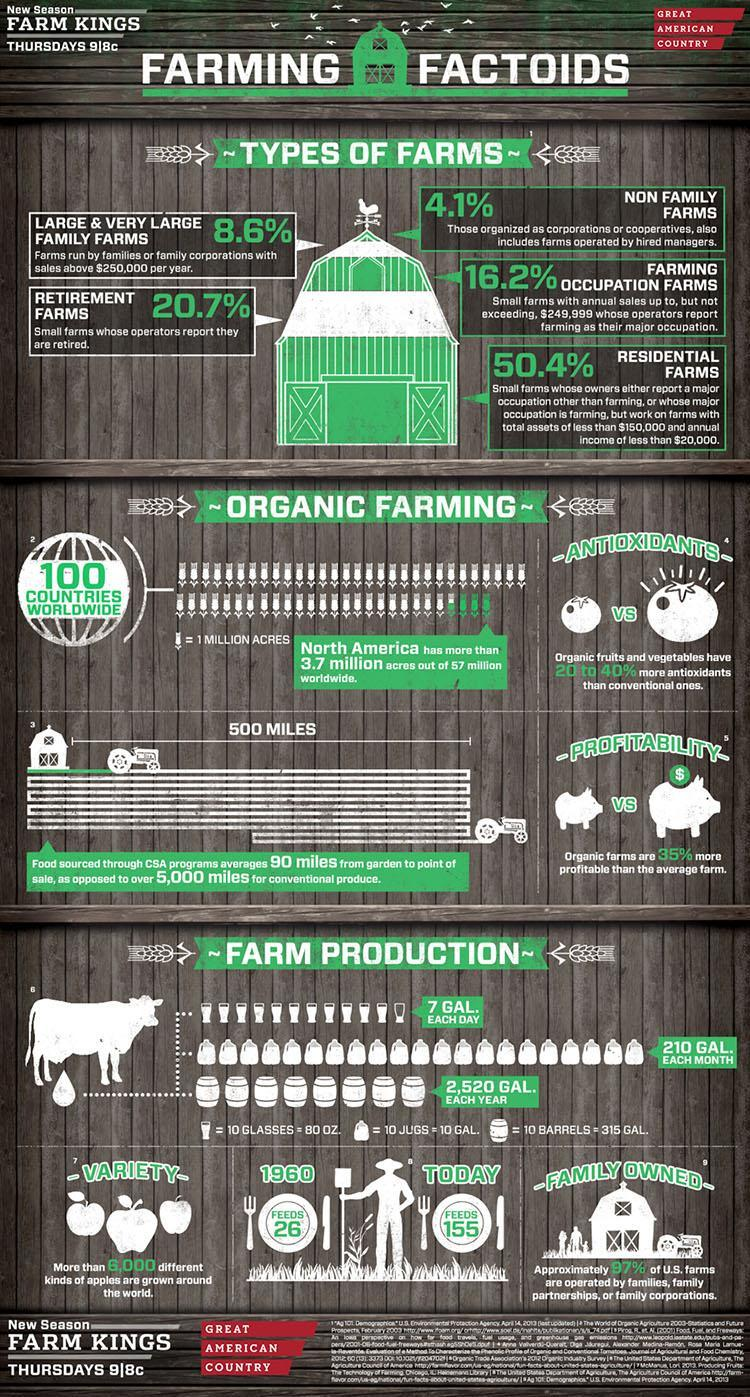How many glasses are required to store 7 gallons of milk every day?
Answer the question with a short phrase. 112 How many barrels are required to store 2520 gallons of milk every year? 80 barrels How many jugs are required to store 210 gallons of milk every month? 210 jugs How many types of farms are mentioned in the document? 5 Which is the most common type of farm that has a low income contribution? Residential Farms 